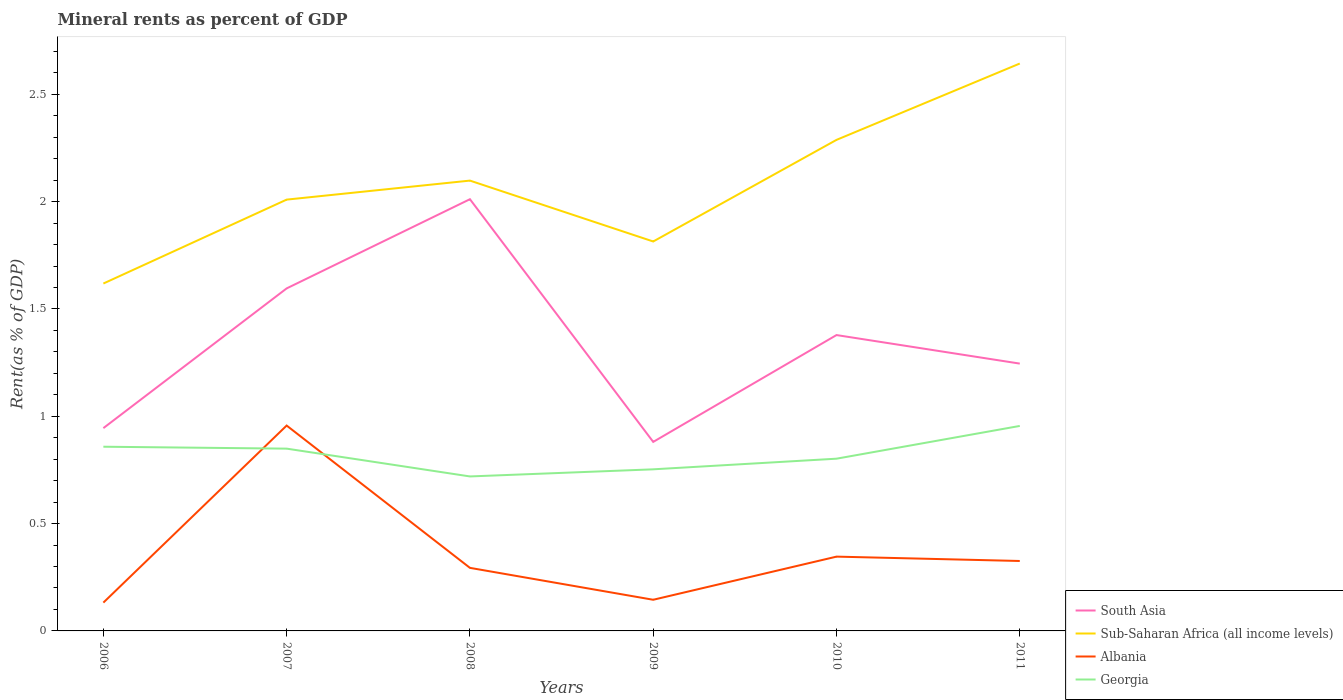Does the line corresponding to South Asia intersect with the line corresponding to Albania?
Your response must be concise. No. Is the number of lines equal to the number of legend labels?
Provide a succinct answer. Yes. Across all years, what is the maximum mineral rent in Georgia?
Offer a terse response. 0.72. What is the total mineral rent in Sub-Saharan Africa (all income levels) in the graph?
Keep it short and to the point. 0.28. What is the difference between the highest and the second highest mineral rent in Sub-Saharan Africa (all income levels)?
Your answer should be very brief. 1.03. Is the mineral rent in Albania strictly greater than the mineral rent in South Asia over the years?
Provide a short and direct response. Yes. Are the values on the major ticks of Y-axis written in scientific E-notation?
Offer a very short reply. No. Where does the legend appear in the graph?
Offer a very short reply. Bottom right. How many legend labels are there?
Your answer should be very brief. 4. What is the title of the graph?
Give a very brief answer. Mineral rents as percent of GDP. What is the label or title of the X-axis?
Your answer should be compact. Years. What is the label or title of the Y-axis?
Your answer should be compact. Rent(as % of GDP). What is the Rent(as % of GDP) in South Asia in 2006?
Your answer should be very brief. 0.94. What is the Rent(as % of GDP) in Sub-Saharan Africa (all income levels) in 2006?
Offer a very short reply. 1.62. What is the Rent(as % of GDP) of Albania in 2006?
Offer a very short reply. 0.13. What is the Rent(as % of GDP) of Georgia in 2006?
Ensure brevity in your answer.  0.86. What is the Rent(as % of GDP) of South Asia in 2007?
Provide a short and direct response. 1.6. What is the Rent(as % of GDP) of Sub-Saharan Africa (all income levels) in 2007?
Your answer should be very brief. 2.01. What is the Rent(as % of GDP) of Albania in 2007?
Make the answer very short. 0.96. What is the Rent(as % of GDP) of Georgia in 2007?
Offer a terse response. 0.85. What is the Rent(as % of GDP) of South Asia in 2008?
Your answer should be very brief. 2.01. What is the Rent(as % of GDP) in Sub-Saharan Africa (all income levels) in 2008?
Ensure brevity in your answer.  2.1. What is the Rent(as % of GDP) in Albania in 2008?
Keep it short and to the point. 0.29. What is the Rent(as % of GDP) in Georgia in 2008?
Offer a very short reply. 0.72. What is the Rent(as % of GDP) in South Asia in 2009?
Provide a short and direct response. 0.88. What is the Rent(as % of GDP) in Sub-Saharan Africa (all income levels) in 2009?
Provide a succinct answer. 1.81. What is the Rent(as % of GDP) in Albania in 2009?
Offer a terse response. 0.15. What is the Rent(as % of GDP) of Georgia in 2009?
Ensure brevity in your answer.  0.75. What is the Rent(as % of GDP) in South Asia in 2010?
Your answer should be very brief. 1.38. What is the Rent(as % of GDP) in Sub-Saharan Africa (all income levels) in 2010?
Provide a succinct answer. 2.29. What is the Rent(as % of GDP) in Albania in 2010?
Keep it short and to the point. 0.35. What is the Rent(as % of GDP) in Georgia in 2010?
Your answer should be compact. 0.8. What is the Rent(as % of GDP) of South Asia in 2011?
Provide a short and direct response. 1.25. What is the Rent(as % of GDP) in Sub-Saharan Africa (all income levels) in 2011?
Offer a terse response. 2.64. What is the Rent(as % of GDP) of Albania in 2011?
Offer a terse response. 0.33. What is the Rent(as % of GDP) of Georgia in 2011?
Make the answer very short. 0.96. Across all years, what is the maximum Rent(as % of GDP) of South Asia?
Provide a short and direct response. 2.01. Across all years, what is the maximum Rent(as % of GDP) of Sub-Saharan Africa (all income levels)?
Your answer should be compact. 2.64. Across all years, what is the maximum Rent(as % of GDP) in Albania?
Your answer should be very brief. 0.96. Across all years, what is the maximum Rent(as % of GDP) of Georgia?
Your answer should be compact. 0.96. Across all years, what is the minimum Rent(as % of GDP) in South Asia?
Provide a short and direct response. 0.88. Across all years, what is the minimum Rent(as % of GDP) of Sub-Saharan Africa (all income levels)?
Keep it short and to the point. 1.62. Across all years, what is the minimum Rent(as % of GDP) of Albania?
Your response must be concise. 0.13. Across all years, what is the minimum Rent(as % of GDP) in Georgia?
Ensure brevity in your answer.  0.72. What is the total Rent(as % of GDP) in South Asia in the graph?
Your response must be concise. 8.06. What is the total Rent(as % of GDP) in Sub-Saharan Africa (all income levels) in the graph?
Give a very brief answer. 12.47. What is the total Rent(as % of GDP) in Albania in the graph?
Your answer should be compact. 2.2. What is the total Rent(as % of GDP) in Georgia in the graph?
Give a very brief answer. 4.94. What is the difference between the Rent(as % of GDP) in South Asia in 2006 and that in 2007?
Give a very brief answer. -0.65. What is the difference between the Rent(as % of GDP) of Sub-Saharan Africa (all income levels) in 2006 and that in 2007?
Offer a very short reply. -0.39. What is the difference between the Rent(as % of GDP) of Albania in 2006 and that in 2007?
Keep it short and to the point. -0.82. What is the difference between the Rent(as % of GDP) in Georgia in 2006 and that in 2007?
Offer a very short reply. 0.01. What is the difference between the Rent(as % of GDP) in South Asia in 2006 and that in 2008?
Your answer should be very brief. -1.07. What is the difference between the Rent(as % of GDP) in Sub-Saharan Africa (all income levels) in 2006 and that in 2008?
Your response must be concise. -0.48. What is the difference between the Rent(as % of GDP) of Albania in 2006 and that in 2008?
Provide a short and direct response. -0.16. What is the difference between the Rent(as % of GDP) of Georgia in 2006 and that in 2008?
Keep it short and to the point. 0.14. What is the difference between the Rent(as % of GDP) in South Asia in 2006 and that in 2009?
Make the answer very short. 0.06. What is the difference between the Rent(as % of GDP) in Sub-Saharan Africa (all income levels) in 2006 and that in 2009?
Ensure brevity in your answer.  -0.2. What is the difference between the Rent(as % of GDP) in Albania in 2006 and that in 2009?
Offer a terse response. -0.01. What is the difference between the Rent(as % of GDP) in Georgia in 2006 and that in 2009?
Provide a short and direct response. 0.11. What is the difference between the Rent(as % of GDP) in South Asia in 2006 and that in 2010?
Your answer should be compact. -0.43. What is the difference between the Rent(as % of GDP) in Sub-Saharan Africa (all income levels) in 2006 and that in 2010?
Your response must be concise. -0.67. What is the difference between the Rent(as % of GDP) in Albania in 2006 and that in 2010?
Your answer should be very brief. -0.21. What is the difference between the Rent(as % of GDP) of Georgia in 2006 and that in 2010?
Offer a very short reply. 0.06. What is the difference between the Rent(as % of GDP) of South Asia in 2006 and that in 2011?
Keep it short and to the point. -0.3. What is the difference between the Rent(as % of GDP) in Sub-Saharan Africa (all income levels) in 2006 and that in 2011?
Offer a very short reply. -1.03. What is the difference between the Rent(as % of GDP) of Albania in 2006 and that in 2011?
Your answer should be very brief. -0.19. What is the difference between the Rent(as % of GDP) of Georgia in 2006 and that in 2011?
Offer a terse response. -0.1. What is the difference between the Rent(as % of GDP) in South Asia in 2007 and that in 2008?
Provide a short and direct response. -0.42. What is the difference between the Rent(as % of GDP) of Sub-Saharan Africa (all income levels) in 2007 and that in 2008?
Provide a short and direct response. -0.09. What is the difference between the Rent(as % of GDP) in Albania in 2007 and that in 2008?
Your answer should be very brief. 0.66. What is the difference between the Rent(as % of GDP) in Georgia in 2007 and that in 2008?
Offer a terse response. 0.13. What is the difference between the Rent(as % of GDP) in South Asia in 2007 and that in 2009?
Give a very brief answer. 0.72. What is the difference between the Rent(as % of GDP) of Sub-Saharan Africa (all income levels) in 2007 and that in 2009?
Offer a terse response. 0.2. What is the difference between the Rent(as % of GDP) of Albania in 2007 and that in 2009?
Give a very brief answer. 0.81. What is the difference between the Rent(as % of GDP) in Georgia in 2007 and that in 2009?
Your response must be concise. 0.1. What is the difference between the Rent(as % of GDP) in South Asia in 2007 and that in 2010?
Offer a terse response. 0.22. What is the difference between the Rent(as % of GDP) of Sub-Saharan Africa (all income levels) in 2007 and that in 2010?
Your answer should be very brief. -0.28. What is the difference between the Rent(as % of GDP) in Albania in 2007 and that in 2010?
Ensure brevity in your answer.  0.61. What is the difference between the Rent(as % of GDP) in Georgia in 2007 and that in 2010?
Your answer should be compact. 0.05. What is the difference between the Rent(as % of GDP) in South Asia in 2007 and that in 2011?
Your answer should be compact. 0.35. What is the difference between the Rent(as % of GDP) in Sub-Saharan Africa (all income levels) in 2007 and that in 2011?
Your response must be concise. -0.63. What is the difference between the Rent(as % of GDP) of Albania in 2007 and that in 2011?
Offer a very short reply. 0.63. What is the difference between the Rent(as % of GDP) in Georgia in 2007 and that in 2011?
Keep it short and to the point. -0.11. What is the difference between the Rent(as % of GDP) in South Asia in 2008 and that in 2009?
Ensure brevity in your answer.  1.13. What is the difference between the Rent(as % of GDP) in Sub-Saharan Africa (all income levels) in 2008 and that in 2009?
Your answer should be compact. 0.28. What is the difference between the Rent(as % of GDP) in Albania in 2008 and that in 2009?
Provide a short and direct response. 0.15. What is the difference between the Rent(as % of GDP) of Georgia in 2008 and that in 2009?
Give a very brief answer. -0.03. What is the difference between the Rent(as % of GDP) of South Asia in 2008 and that in 2010?
Give a very brief answer. 0.63. What is the difference between the Rent(as % of GDP) in Sub-Saharan Africa (all income levels) in 2008 and that in 2010?
Offer a terse response. -0.19. What is the difference between the Rent(as % of GDP) of Albania in 2008 and that in 2010?
Give a very brief answer. -0.05. What is the difference between the Rent(as % of GDP) of Georgia in 2008 and that in 2010?
Your response must be concise. -0.08. What is the difference between the Rent(as % of GDP) in South Asia in 2008 and that in 2011?
Your response must be concise. 0.77. What is the difference between the Rent(as % of GDP) in Sub-Saharan Africa (all income levels) in 2008 and that in 2011?
Make the answer very short. -0.55. What is the difference between the Rent(as % of GDP) of Albania in 2008 and that in 2011?
Your answer should be very brief. -0.03. What is the difference between the Rent(as % of GDP) of Georgia in 2008 and that in 2011?
Provide a succinct answer. -0.24. What is the difference between the Rent(as % of GDP) in South Asia in 2009 and that in 2010?
Your answer should be very brief. -0.5. What is the difference between the Rent(as % of GDP) in Sub-Saharan Africa (all income levels) in 2009 and that in 2010?
Keep it short and to the point. -0.47. What is the difference between the Rent(as % of GDP) in Albania in 2009 and that in 2010?
Offer a terse response. -0.2. What is the difference between the Rent(as % of GDP) in Georgia in 2009 and that in 2010?
Offer a terse response. -0.05. What is the difference between the Rent(as % of GDP) of South Asia in 2009 and that in 2011?
Provide a succinct answer. -0.36. What is the difference between the Rent(as % of GDP) of Sub-Saharan Africa (all income levels) in 2009 and that in 2011?
Your answer should be very brief. -0.83. What is the difference between the Rent(as % of GDP) of Albania in 2009 and that in 2011?
Give a very brief answer. -0.18. What is the difference between the Rent(as % of GDP) in Georgia in 2009 and that in 2011?
Your answer should be very brief. -0.2. What is the difference between the Rent(as % of GDP) of South Asia in 2010 and that in 2011?
Make the answer very short. 0.13. What is the difference between the Rent(as % of GDP) in Sub-Saharan Africa (all income levels) in 2010 and that in 2011?
Provide a succinct answer. -0.36. What is the difference between the Rent(as % of GDP) of Albania in 2010 and that in 2011?
Your answer should be very brief. 0.02. What is the difference between the Rent(as % of GDP) in Georgia in 2010 and that in 2011?
Offer a very short reply. -0.15. What is the difference between the Rent(as % of GDP) of South Asia in 2006 and the Rent(as % of GDP) of Sub-Saharan Africa (all income levels) in 2007?
Provide a short and direct response. -1.06. What is the difference between the Rent(as % of GDP) in South Asia in 2006 and the Rent(as % of GDP) in Albania in 2007?
Offer a terse response. -0.01. What is the difference between the Rent(as % of GDP) of South Asia in 2006 and the Rent(as % of GDP) of Georgia in 2007?
Keep it short and to the point. 0.1. What is the difference between the Rent(as % of GDP) in Sub-Saharan Africa (all income levels) in 2006 and the Rent(as % of GDP) in Albania in 2007?
Your response must be concise. 0.66. What is the difference between the Rent(as % of GDP) of Sub-Saharan Africa (all income levels) in 2006 and the Rent(as % of GDP) of Georgia in 2007?
Make the answer very short. 0.77. What is the difference between the Rent(as % of GDP) of Albania in 2006 and the Rent(as % of GDP) of Georgia in 2007?
Ensure brevity in your answer.  -0.72. What is the difference between the Rent(as % of GDP) of South Asia in 2006 and the Rent(as % of GDP) of Sub-Saharan Africa (all income levels) in 2008?
Your answer should be very brief. -1.15. What is the difference between the Rent(as % of GDP) in South Asia in 2006 and the Rent(as % of GDP) in Albania in 2008?
Provide a succinct answer. 0.65. What is the difference between the Rent(as % of GDP) of South Asia in 2006 and the Rent(as % of GDP) of Georgia in 2008?
Provide a short and direct response. 0.23. What is the difference between the Rent(as % of GDP) in Sub-Saharan Africa (all income levels) in 2006 and the Rent(as % of GDP) in Albania in 2008?
Make the answer very short. 1.32. What is the difference between the Rent(as % of GDP) in Sub-Saharan Africa (all income levels) in 2006 and the Rent(as % of GDP) in Georgia in 2008?
Offer a very short reply. 0.9. What is the difference between the Rent(as % of GDP) of Albania in 2006 and the Rent(as % of GDP) of Georgia in 2008?
Provide a succinct answer. -0.59. What is the difference between the Rent(as % of GDP) of South Asia in 2006 and the Rent(as % of GDP) of Sub-Saharan Africa (all income levels) in 2009?
Your response must be concise. -0.87. What is the difference between the Rent(as % of GDP) of South Asia in 2006 and the Rent(as % of GDP) of Albania in 2009?
Give a very brief answer. 0.8. What is the difference between the Rent(as % of GDP) of South Asia in 2006 and the Rent(as % of GDP) of Georgia in 2009?
Offer a terse response. 0.19. What is the difference between the Rent(as % of GDP) in Sub-Saharan Africa (all income levels) in 2006 and the Rent(as % of GDP) in Albania in 2009?
Ensure brevity in your answer.  1.47. What is the difference between the Rent(as % of GDP) of Sub-Saharan Africa (all income levels) in 2006 and the Rent(as % of GDP) of Georgia in 2009?
Your answer should be very brief. 0.87. What is the difference between the Rent(as % of GDP) in Albania in 2006 and the Rent(as % of GDP) in Georgia in 2009?
Offer a terse response. -0.62. What is the difference between the Rent(as % of GDP) in South Asia in 2006 and the Rent(as % of GDP) in Sub-Saharan Africa (all income levels) in 2010?
Your answer should be compact. -1.34. What is the difference between the Rent(as % of GDP) in South Asia in 2006 and the Rent(as % of GDP) in Albania in 2010?
Ensure brevity in your answer.  0.6. What is the difference between the Rent(as % of GDP) of South Asia in 2006 and the Rent(as % of GDP) of Georgia in 2010?
Your response must be concise. 0.14. What is the difference between the Rent(as % of GDP) of Sub-Saharan Africa (all income levels) in 2006 and the Rent(as % of GDP) of Albania in 2010?
Provide a succinct answer. 1.27. What is the difference between the Rent(as % of GDP) in Sub-Saharan Africa (all income levels) in 2006 and the Rent(as % of GDP) in Georgia in 2010?
Give a very brief answer. 0.82. What is the difference between the Rent(as % of GDP) of Albania in 2006 and the Rent(as % of GDP) of Georgia in 2010?
Make the answer very short. -0.67. What is the difference between the Rent(as % of GDP) in South Asia in 2006 and the Rent(as % of GDP) in Sub-Saharan Africa (all income levels) in 2011?
Provide a succinct answer. -1.7. What is the difference between the Rent(as % of GDP) of South Asia in 2006 and the Rent(as % of GDP) of Albania in 2011?
Provide a succinct answer. 0.62. What is the difference between the Rent(as % of GDP) in South Asia in 2006 and the Rent(as % of GDP) in Georgia in 2011?
Offer a very short reply. -0.01. What is the difference between the Rent(as % of GDP) of Sub-Saharan Africa (all income levels) in 2006 and the Rent(as % of GDP) of Albania in 2011?
Give a very brief answer. 1.29. What is the difference between the Rent(as % of GDP) in Sub-Saharan Africa (all income levels) in 2006 and the Rent(as % of GDP) in Georgia in 2011?
Provide a short and direct response. 0.66. What is the difference between the Rent(as % of GDP) of Albania in 2006 and the Rent(as % of GDP) of Georgia in 2011?
Offer a very short reply. -0.82. What is the difference between the Rent(as % of GDP) in South Asia in 2007 and the Rent(as % of GDP) in Sub-Saharan Africa (all income levels) in 2008?
Keep it short and to the point. -0.5. What is the difference between the Rent(as % of GDP) in South Asia in 2007 and the Rent(as % of GDP) in Albania in 2008?
Give a very brief answer. 1.3. What is the difference between the Rent(as % of GDP) in South Asia in 2007 and the Rent(as % of GDP) in Georgia in 2008?
Your answer should be very brief. 0.88. What is the difference between the Rent(as % of GDP) of Sub-Saharan Africa (all income levels) in 2007 and the Rent(as % of GDP) of Albania in 2008?
Make the answer very short. 1.72. What is the difference between the Rent(as % of GDP) in Sub-Saharan Africa (all income levels) in 2007 and the Rent(as % of GDP) in Georgia in 2008?
Your answer should be compact. 1.29. What is the difference between the Rent(as % of GDP) in Albania in 2007 and the Rent(as % of GDP) in Georgia in 2008?
Your answer should be very brief. 0.24. What is the difference between the Rent(as % of GDP) of South Asia in 2007 and the Rent(as % of GDP) of Sub-Saharan Africa (all income levels) in 2009?
Provide a short and direct response. -0.22. What is the difference between the Rent(as % of GDP) of South Asia in 2007 and the Rent(as % of GDP) of Albania in 2009?
Make the answer very short. 1.45. What is the difference between the Rent(as % of GDP) of South Asia in 2007 and the Rent(as % of GDP) of Georgia in 2009?
Your response must be concise. 0.84. What is the difference between the Rent(as % of GDP) of Sub-Saharan Africa (all income levels) in 2007 and the Rent(as % of GDP) of Albania in 2009?
Your answer should be compact. 1.86. What is the difference between the Rent(as % of GDP) of Sub-Saharan Africa (all income levels) in 2007 and the Rent(as % of GDP) of Georgia in 2009?
Your answer should be very brief. 1.26. What is the difference between the Rent(as % of GDP) of Albania in 2007 and the Rent(as % of GDP) of Georgia in 2009?
Provide a short and direct response. 0.2. What is the difference between the Rent(as % of GDP) in South Asia in 2007 and the Rent(as % of GDP) in Sub-Saharan Africa (all income levels) in 2010?
Your answer should be very brief. -0.69. What is the difference between the Rent(as % of GDP) of South Asia in 2007 and the Rent(as % of GDP) of Albania in 2010?
Your response must be concise. 1.25. What is the difference between the Rent(as % of GDP) of South Asia in 2007 and the Rent(as % of GDP) of Georgia in 2010?
Provide a short and direct response. 0.79. What is the difference between the Rent(as % of GDP) in Sub-Saharan Africa (all income levels) in 2007 and the Rent(as % of GDP) in Albania in 2010?
Keep it short and to the point. 1.66. What is the difference between the Rent(as % of GDP) in Sub-Saharan Africa (all income levels) in 2007 and the Rent(as % of GDP) in Georgia in 2010?
Make the answer very short. 1.21. What is the difference between the Rent(as % of GDP) in Albania in 2007 and the Rent(as % of GDP) in Georgia in 2010?
Offer a terse response. 0.15. What is the difference between the Rent(as % of GDP) of South Asia in 2007 and the Rent(as % of GDP) of Sub-Saharan Africa (all income levels) in 2011?
Provide a short and direct response. -1.05. What is the difference between the Rent(as % of GDP) of South Asia in 2007 and the Rent(as % of GDP) of Albania in 2011?
Keep it short and to the point. 1.27. What is the difference between the Rent(as % of GDP) in South Asia in 2007 and the Rent(as % of GDP) in Georgia in 2011?
Offer a very short reply. 0.64. What is the difference between the Rent(as % of GDP) of Sub-Saharan Africa (all income levels) in 2007 and the Rent(as % of GDP) of Albania in 2011?
Provide a short and direct response. 1.68. What is the difference between the Rent(as % of GDP) in Sub-Saharan Africa (all income levels) in 2007 and the Rent(as % of GDP) in Georgia in 2011?
Make the answer very short. 1.05. What is the difference between the Rent(as % of GDP) in Albania in 2007 and the Rent(as % of GDP) in Georgia in 2011?
Keep it short and to the point. 0. What is the difference between the Rent(as % of GDP) in South Asia in 2008 and the Rent(as % of GDP) in Sub-Saharan Africa (all income levels) in 2009?
Give a very brief answer. 0.2. What is the difference between the Rent(as % of GDP) in South Asia in 2008 and the Rent(as % of GDP) in Albania in 2009?
Provide a short and direct response. 1.87. What is the difference between the Rent(as % of GDP) of South Asia in 2008 and the Rent(as % of GDP) of Georgia in 2009?
Your response must be concise. 1.26. What is the difference between the Rent(as % of GDP) in Sub-Saharan Africa (all income levels) in 2008 and the Rent(as % of GDP) in Albania in 2009?
Your answer should be very brief. 1.95. What is the difference between the Rent(as % of GDP) of Sub-Saharan Africa (all income levels) in 2008 and the Rent(as % of GDP) of Georgia in 2009?
Your response must be concise. 1.35. What is the difference between the Rent(as % of GDP) of Albania in 2008 and the Rent(as % of GDP) of Georgia in 2009?
Ensure brevity in your answer.  -0.46. What is the difference between the Rent(as % of GDP) of South Asia in 2008 and the Rent(as % of GDP) of Sub-Saharan Africa (all income levels) in 2010?
Provide a succinct answer. -0.28. What is the difference between the Rent(as % of GDP) in South Asia in 2008 and the Rent(as % of GDP) in Albania in 2010?
Provide a succinct answer. 1.67. What is the difference between the Rent(as % of GDP) in South Asia in 2008 and the Rent(as % of GDP) in Georgia in 2010?
Give a very brief answer. 1.21. What is the difference between the Rent(as % of GDP) of Sub-Saharan Africa (all income levels) in 2008 and the Rent(as % of GDP) of Albania in 2010?
Give a very brief answer. 1.75. What is the difference between the Rent(as % of GDP) in Sub-Saharan Africa (all income levels) in 2008 and the Rent(as % of GDP) in Georgia in 2010?
Your response must be concise. 1.3. What is the difference between the Rent(as % of GDP) of Albania in 2008 and the Rent(as % of GDP) of Georgia in 2010?
Provide a short and direct response. -0.51. What is the difference between the Rent(as % of GDP) of South Asia in 2008 and the Rent(as % of GDP) of Sub-Saharan Africa (all income levels) in 2011?
Keep it short and to the point. -0.63. What is the difference between the Rent(as % of GDP) of South Asia in 2008 and the Rent(as % of GDP) of Albania in 2011?
Make the answer very short. 1.69. What is the difference between the Rent(as % of GDP) in South Asia in 2008 and the Rent(as % of GDP) in Georgia in 2011?
Keep it short and to the point. 1.06. What is the difference between the Rent(as % of GDP) of Sub-Saharan Africa (all income levels) in 2008 and the Rent(as % of GDP) of Albania in 2011?
Give a very brief answer. 1.77. What is the difference between the Rent(as % of GDP) of Sub-Saharan Africa (all income levels) in 2008 and the Rent(as % of GDP) of Georgia in 2011?
Keep it short and to the point. 1.14. What is the difference between the Rent(as % of GDP) of Albania in 2008 and the Rent(as % of GDP) of Georgia in 2011?
Give a very brief answer. -0.66. What is the difference between the Rent(as % of GDP) in South Asia in 2009 and the Rent(as % of GDP) in Sub-Saharan Africa (all income levels) in 2010?
Provide a succinct answer. -1.41. What is the difference between the Rent(as % of GDP) of South Asia in 2009 and the Rent(as % of GDP) of Albania in 2010?
Your answer should be compact. 0.53. What is the difference between the Rent(as % of GDP) of South Asia in 2009 and the Rent(as % of GDP) of Georgia in 2010?
Give a very brief answer. 0.08. What is the difference between the Rent(as % of GDP) of Sub-Saharan Africa (all income levels) in 2009 and the Rent(as % of GDP) of Albania in 2010?
Provide a short and direct response. 1.47. What is the difference between the Rent(as % of GDP) of Albania in 2009 and the Rent(as % of GDP) of Georgia in 2010?
Ensure brevity in your answer.  -0.66. What is the difference between the Rent(as % of GDP) of South Asia in 2009 and the Rent(as % of GDP) of Sub-Saharan Africa (all income levels) in 2011?
Give a very brief answer. -1.76. What is the difference between the Rent(as % of GDP) of South Asia in 2009 and the Rent(as % of GDP) of Albania in 2011?
Your answer should be very brief. 0.55. What is the difference between the Rent(as % of GDP) in South Asia in 2009 and the Rent(as % of GDP) in Georgia in 2011?
Your answer should be compact. -0.07. What is the difference between the Rent(as % of GDP) in Sub-Saharan Africa (all income levels) in 2009 and the Rent(as % of GDP) in Albania in 2011?
Your answer should be very brief. 1.49. What is the difference between the Rent(as % of GDP) in Sub-Saharan Africa (all income levels) in 2009 and the Rent(as % of GDP) in Georgia in 2011?
Your answer should be compact. 0.86. What is the difference between the Rent(as % of GDP) in Albania in 2009 and the Rent(as % of GDP) in Georgia in 2011?
Offer a very short reply. -0.81. What is the difference between the Rent(as % of GDP) in South Asia in 2010 and the Rent(as % of GDP) in Sub-Saharan Africa (all income levels) in 2011?
Make the answer very short. -1.27. What is the difference between the Rent(as % of GDP) of South Asia in 2010 and the Rent(as % of GDP) of Albania in 2011?
Ensure brevity in your answer.  1.05. What is the difference between the Rent(as % of GDP) in South Asia in 2010 and the Rent(as % of GDP) in Georgia in 2011?
Provide a short and direct response. 0.42. What is the difference between the Rent(as % of GDP) of Sub-Saharan Africa (all income levels) in 2010 and the Rent(as % of GDP) of Albania in 2011?
Your answer should be compact. 1.96. What is the difference between the Rent(as % of GDP) in Sub-Saharan Africa (all income levels) in 2010 and the Rent(as % of GDP) in Georgia in 2011?
Your response must be concise. 1.33. What is the difference between the Rent(as % of GDP) in Albania in 2010 and the Rent(as % of GDP) in Georgia in 2011?
Offer a terse response. -0.61. What is the average Rent(as % of GDP) in South Asia per year?
Provide a short and direct response. 1.34. What is the average Rent(as % of GDP) in Sub-Saharan Africa (all income levels) per year?
Provide a succinct answer. 2.08. What is the average Rent(as % of GDP) of Albania per year?
Provide a succinct answer. 0.37. What is the average Rent(as % of GDP) of Georgia per year?
Your answer should be very brief. 0.82. In the year 2006, what is the difference between the Rent(as % of GDP) of South Asia and Rent(as % of GDP) of Sub-Saharan Africa (all income levels)?
Ensure brevity in your answer.  -0.67. In the year 2006, what is the difference between the Rent(as % of GDP) in South Asia and Rent(as % of GDP) in Albania?
Provide a succinct answer. 0.81. In the year 2006, what is the difference between the Rent(as % of GDP) of South Asia and Rent(as % of GDP) of Georgia?
Keep it short and to the point. 0.09. In the year 2006, what is the difference between the Rent(as % of GDP) in Sub-Saharan Africa (all income levels) and Rent(as % of GDP) in Albania?
Offer a very short reply. 1.49. In the year 2006, what is the difference between the Rent(as % of GDP) of Sub-Saharan Africa (all income levels) and Rent(as % of GDP) of Georgia?
Keep it short and to the point. 0.76. In the year 2006, what is the difference between the Rent(as % of GDP) of Albania and Rent(as % of GDP) of Georgia?
Offer a very short reply. -0.73. In the year 2007, what is the difference between the Rent(as % of GDP) in South Asia and Rent(as % of GDP) in Sub-Saharan Africa (all income levels)?
Provide a succinct answer. -0.41. In the year 2007, what is the difference between the Rent(as % of GDP) of South Asia and Rent(as % of GDP) of Albania?
Your answer should be compact. 0.64. In the year 2007, what is the difference between the Rent(as % of GDP) in South Asia and Rent(as % of GDP) in Georgia?
Your response must be concise. 0.75. In the year 2007, what is the difference between the Rent(as % of GDP) of Sub-Saharan Africa (all income levels) and Rent(as % of GDP) of Albania?
Ensure brevity in your answer.  1.05. In the year 2007, what is the difference between the Rent(as % of GDP) in Sub-Saharan Africa (all income levels) and Rent(as % of GDP) in Georgia?
Your answer should be very brief. 1.16. In the year 2007, what is the difference between the Rent(as % of GDP) of Albania and Rent(as % of GDP) of Georgia?
Your response must be concise. 0.11. In the year 2008, what is the difference between the Rent(as % of GDP) of South Asia and Rent(as % of GDP) of Sub-Saharan Africa (all income levels)?
Your answer should be compact. -0.09. In the year 2008, what is the difference between the Rent(as % of GDP) of South Asia and Rent(as % of GDP) of Albania?
Give a very brief answer. 1.72. In the year 2008, what is the difference between the Rent(as % of GDP) of South Asia and Rent(as % of GDP) of Georgia?
Keep it short and to the point. 1.29. In the year 2008, what is the difference between the Rent(as % of GDP) of Sub-Saharan Africa (all income levels) and Rent(as % of GDP) of Albania?
Offer a very short reply. 1.8. In the year 2008, what is the difference between the Rent(as % of GDP) of Sub-Saharan Africa (all income levels) and Rent(as % of GDP) of Georgia?
Make the answer very short. 1.38. In the year 2008, what is the difference between the Rent(as % of GDP) of Albania and Rent(as % of GDP) of Georgia?
Your answer should be very brief. -0.43. In the year 2009, what is the difference between the Rent(as % of GDP) of South Asia and Rent(as % of GDP) of Sub-Saharan Africa (all income levels)?
Ensure brevity in your answer.  -0.93. In the year 2009, what is the difference between the Rent(as % of GDP) of South Asia and Rent(as % of GDP) of Albania?
Ensure brevity in your answer.  0.74. In the year 2009, what is the difference between the Rent(as % of GDP) of South Asia and Rent(as % of GDP) of Georgia?
Your response must be concise. 0.13. In the year 2009, what is the difference between the Rent(as % of GDP) of Sub-Saharan Africa (all income levels) and Rent(as % of GDP) of Albania?
Your response must be concise. 1.67. In the year 2009, what is the difference between the Rent(as % of GDP) of Sub-Saharan Africa (all income levels) and Rent(as % of GDP) of Georgia?
Give a very brief answer. 1.06. In the year 2009, what is the difference between the Rent(as % of GDP) of Albania and Rent(as % of GDP) of Georgia?
Make the answer very short. -0.61. In the year 2010, what is the difference between the Rent(as % of GDP) in South Asia and Rent(as % of GDP) in Sub-Saharan Africa (all income levels)?
Ensure brevity in your answer.  -0.91. In the year 2010, what is the difference between the Rent(as % of GDP) of South Asia and Rent(as % of GDP) of Albania?
Give a very brief answer. 1.03. In the year 2010, what is the difference between the Rent(as % of GDP) of South Asia and Rent(as % of GDP) of Georgia?
Offer a very short reply. 0.58. In the year 2010, what is the difference between the Rent(as % of GDP) in Sub-Saharan Africa (all income levels) and Rent(as % of GDP) in Albania?
Your response must be concise. 1.94. In the year 2010, what is the difference between the Rent(as % of GDP) of Sub-Saharan Africa (all income levels) and Rent(as % of GDP) of Georgia?
Ensure brevity in your answer.  1.49. In the year 2010, what is the difference between the Rent(as % of GDP) of Albania and Rent(as % of GDP) of Georgia?
Offer a very short reply. -0.46. In the year 2011, what is the difference between the Rent(as % of GDP) in South Asia and Rent(as % of GDP) in Sub-Saharan Africa (all income levels)?
Provide a short and direct response. -1.4. In the year 2011, what is the difference between the Rent(as % of GDP) in South Asia and Rent(as % of GDP) in Albania?
Ensure brevity in your answer.  0.92. In the year 2011, what is the difference between the Rent(as % of GDP) of South Asia and Rent(as % of GDP) of Georgia?
Offer a very short reply. 0.29. In the year 2011, what is the difference between the Rent(as % of GDP) of Sub-Saharan Africa (all income levels) and Rent(as % of GDP) of Albania?
Ensure brevity in your answer.  2.32. In the year 2011, what is the difference between the Rent(as % of GDP) of Sub-Saharan Africa (all income levels) and Rent(as % of GDP) of Georgia?
Give a very brief answer. 1.69. In the year 2011, what is the difference between the Rent(as % of GDP) in Albania and Rent(as % of GDP) in Georgia?
Keep it short and to the point. -0.63. What is the ratio of the Rent(as % of GDP) of South Asia in 2006 to that in 2007?
Provide a short and direct response. 0.59. What is the ratio of the Rent(as % of GDP) of Sub-Saharan Africa (all income levels) in 2006 to that in 2007?
Give a very brief answer. 0.81. What is the ratio of the Rent(as % of GDP) in Albania in 2006 to that in 2007?
Provide a succinct answer. 0.14. What is the ratio of the Rent(as % of GDP) of Georgia in 2006 to that in 2007?
Your answer should be very brief. 1.01. What is the ratio of the Rent(as % of GDP) in South Asia in 2006 to that in 2008?
Ensure brevity in your answer.  0.47. What is the ratio of the Rent(as % of GDP) of Sub-Saharan Africa (all income levels) in 2006 to that in 2008?
Your answer should be compact. 0.77. What is the ratio of the Rent(as % of GDP) of Albania in 2006 to that in 2008?
Offer a terse response. 0.45. What is the ratio of the Rent(as % of GDP) of Georgia in 2006 to that in 2008?
Give a very brief answer. 1.19. What is the ratio of the Rent(as % of GDP) of South Asia in 2006 to that in 2009?
Provide a short and direct response. 1.07. What is the ratio of the Rent(as % of GDP) of Sub-Saharan Africa (all income levels) in 2006 to that in 2009?
Your response must be concise. 0.89. What is the ratio of the Rent(as % of GDP) of Albania in 2006 to that in 2009?
Make the answer very short. 0.91. What is the ratio of the Rent(as % of GDP) of Georgia in 2006 to that in 2009?
Ensure brevity in your answer.  1.14. What is the ratio of the Rent(as % of GDP) of South Asia in 2006 to that in 2010?
Give a very brief answer. 0.69. What is the ratio of the Rent(as % of GDP) of Sub-Saharan Africa (all income levels) in 2006 to that in 2010?
Your answer should be compact. 0.71. What is the ratio of the Rent(as % of GDP) in Albania in 2006 to that in 2010?
Keep it short and to the point. 0.38. What is the ratio of the Rent(as % of GDP) of Georgia in 2006 to that in 2010?
Keep it short and to the point. 1.07. What is the ratio of the Rent(as % of GDP) in South Asia in 2006 to that in 2011?
Your response must be concise. 0.76. What is the ratio of the Rent(as % of GDP) in Sub-Saharan Africa (all income levels) in 2006 to that in 2011?
Ensure brevity in your answer.  0.61. What is the ratio of the Rent(as % of GDP) of Albania in 2006 to that in 2011?
Keep it short and to the point. 0.4. What is the ratio of the Rent(as % of GDP) of Georgia in 2006 to that in 2011?
Your response must be concise. 0.9. What is the ratio of the Rent(as % of GDP) of South Asia in 2007 to that in 2008?
Your answer should be very brief. 0.79. What is the ratio of the Rent(as % of GDP) in Sub-Saharan Africa (all income levels) in 2007 to that in 2008?
Keep it short and to the point. 0.96. What is the ratio of the Rent(as % of GDP) of Albania in 2007 to that in 2008?
Offer a very short reply. 3.26. What is the ratio of the Rent(as % of GDP) in Georgia in 2007 to that in 2008?
Offer a terse response. 1.18. What is the ratio of the Rent(as % of GDP) of South Asia in 2007 to that in 2009?
Give a very brief answer. 1.81. What is the ratio of the Rent(as % of GDP) of Sub-Saharan Africa (all income levels) in 2007 to that in 2009?
Offer a very short reply. 1.11. What is the ratio of the Rent(as % of GDP) in Albania in 2007 to that in 2009?
Your response must be concise. 6.59. What is the ratio of the Rent(as % of GDP) of Georgia in 2007 to that in 2009?
Provide a succinct answer. 1.13. What is the ratio of the Rent(as % of GDP) of South Asia in 2007 to that in 2010?
Ensure brevity in your answer.  1.16. What is the ratio of the Rent(as % of GDP) in Sub-Saharan Africa (all income levels) in 2007 to that in 2010?
Your answer should be very brief. 0.88. What is the ratio of the Rent(as % of GDP) of Albania in 2007 to that in 2010?
Keep it short and to the point. 2.76. What is the ratio of the Rent(as % of GDP) of Georgia in 2007 to that in 2010?
Give a very brief answer. 1.06. What is the ratio of the Rent(as % of GDP) in South Asia in 2007 to that in 2011?
Provide a succinct answer. 1.28. What is the ratio of the Rent(as % of GDP) of Sub-Saharan Africa (all income levels) in 2007 to that in 2011?
Make the answer very short. 0.76. What is the ratio of the Rent(as % of GDP) in Albania in 2007 to that in 2011?
Make the answer very short. 2.94. What is the ratio of the Rent(as % of GDP) of Georgia in 2007 to that in 2011?
Give a very brief answer. 0.89. What is the ratio of the Rent(as % of GDP) in South Asia in 2008 to that in 2009?
Offer a terse response. 2.28. What is the ratio of the Rent(as % of GDP) of Sub-Saharan Africa (all income levels) in 2008 to that in 2009?
Ensure brevity in your answer.  1.16. What is the ratio of the Rent(as % of GDP) in Albania in 2008 to that in 2009?
Give a very brief answer. 2.02. What is the ratio of the Rent(as % of GDP) of Georgia in 2008 to that in 2009?
Give a very brief answer. 0.96. What is the ratio of the Rent(as % of GDP) of South Asia in 2008 to that in 2010?
Keep it short and to the point. 1.46. What is the ratio of the Rent(as % of GDP) in Sub-Saharan Africa (all income levels) in 2008 to that in 2010?
Offer a very short reply. 0.92. What is the ratio of the Rent(as % of GDP) of Albania in 2008 to that in 2010?
Offer a very short reply. 0.85. What is the ratio of the Rent(as % of GDP) of Georgia in 2008 to that in 2010?
Ensure brevity in your answer.  0.9. What is the ratio of the Rent(as % of GDP) of South Asia in 2008 to that in 2011?
Give a very brief answer. 1.61. What is the ratio of the Rent(as % of GDP) of Sub-Saharan Africa (all income levels) in 2008 to that in 2011?
Your answer should be very brief. 0.79. What is the ratio of the Rent(as % of GDP) of Albania in 2008 to that in 2011?
Provide a succinct answer. 0.9. What is the ratio of the Rent(as % of GDP) of Georgia in 2008 to that in 2011?
Give a very brief answer. 0.75. What is the ratio of the Rent(as % of GDP) of South Asia in 2009 to that in 2010?
Your answer should be very brief. 0.64. What is the ratio of the Rent(as % of GDP) of Sub-Saharan Africa (all income levels) in 2009 to that in 2010?
Make the answer very short. 0.79. What is the ratio of the Rent(as % of GDP) of Albania in 2009 to that in 2010?
Your response must be concise. 0.42. What is the ratio of the Rent(as % of GDP) in Georgia in 2009 to that in 2010?
Your response must be concise. 0.94. What is the ratio of the Rent(as % of GDP) of South Asia in 2009 to that in 2011?
Give a very brief answer. 0.71. What is the ratio of the Rent(as % of GDP) in Sub-Saharan Africa (all income levels) in 2009 to that in 2011?
Provide a succinct answer. 0.69. What is the ratio of the Rent(as % of GDP) of Albania in 2009 to that in 2011?
Give a very brief answer. 0.45. What is the ratio of the Rent(as % of GDP) in Georgia in 2009 to that in 2011?
Offer a very short reply. 0.79. What is the ratio of the Rent(as % of GDP) in South Asia in 2010 to that in 2011?
Offer a very short reply. 1.11. What is the ratio of the Rent(as % of GDP) of Sub-Saharan Africa (all income levels) in 2010 to that in 2011?
Offer a terse response. 0.87. What is the ratio of the Rent(as % of GDP) in Albania in 2010 to that in 2011?
Provide a succinct answer. 1.06. What is the ratio of the Rent(as % of GDP) in Georgia in 2010 to that in 2011?
Provide a short and direct response. 0.84. What is the difference between the highest and the second highest Rent(as % of GDP) in South Asia?
Keep it short and to the point. 0.42. What is the difference between the highest and the second highest Rent(as % of GDP) in Sub-Saharan Africa (all income levels)?
Your answer should be compact. 0.36. What is the difference between the highest and the second highest Rent(as % of GDP) of Albania?
Ensure brevity in your answer.  0.61. What is the difference between the highest and the second highest Rent(as % of GDP) in Georgia?
Make the answer very short. 0.1. What is the difference between the highest and the lowest Rent(as % of GDP) of South Asia?
Your answer should be compact. 1.13. What is the difference between the highest and the lowest Rent(as % of GDP) in Sub-Saharan Africa (all income levels)?
Your answer should be compact. 1.03. What is the difference between the highest and the lowest Rent(as % of GDP) of Albania?
Offer a terse response. 0.82. What is the difference between the highest and the lowest Rent(as % of GDP) in Georgia?
Your response must be concise. 0.24. 